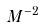<formula> <loc_0><loc_0><loc_500><loc_500>M ^ { - 2 }</formula> 